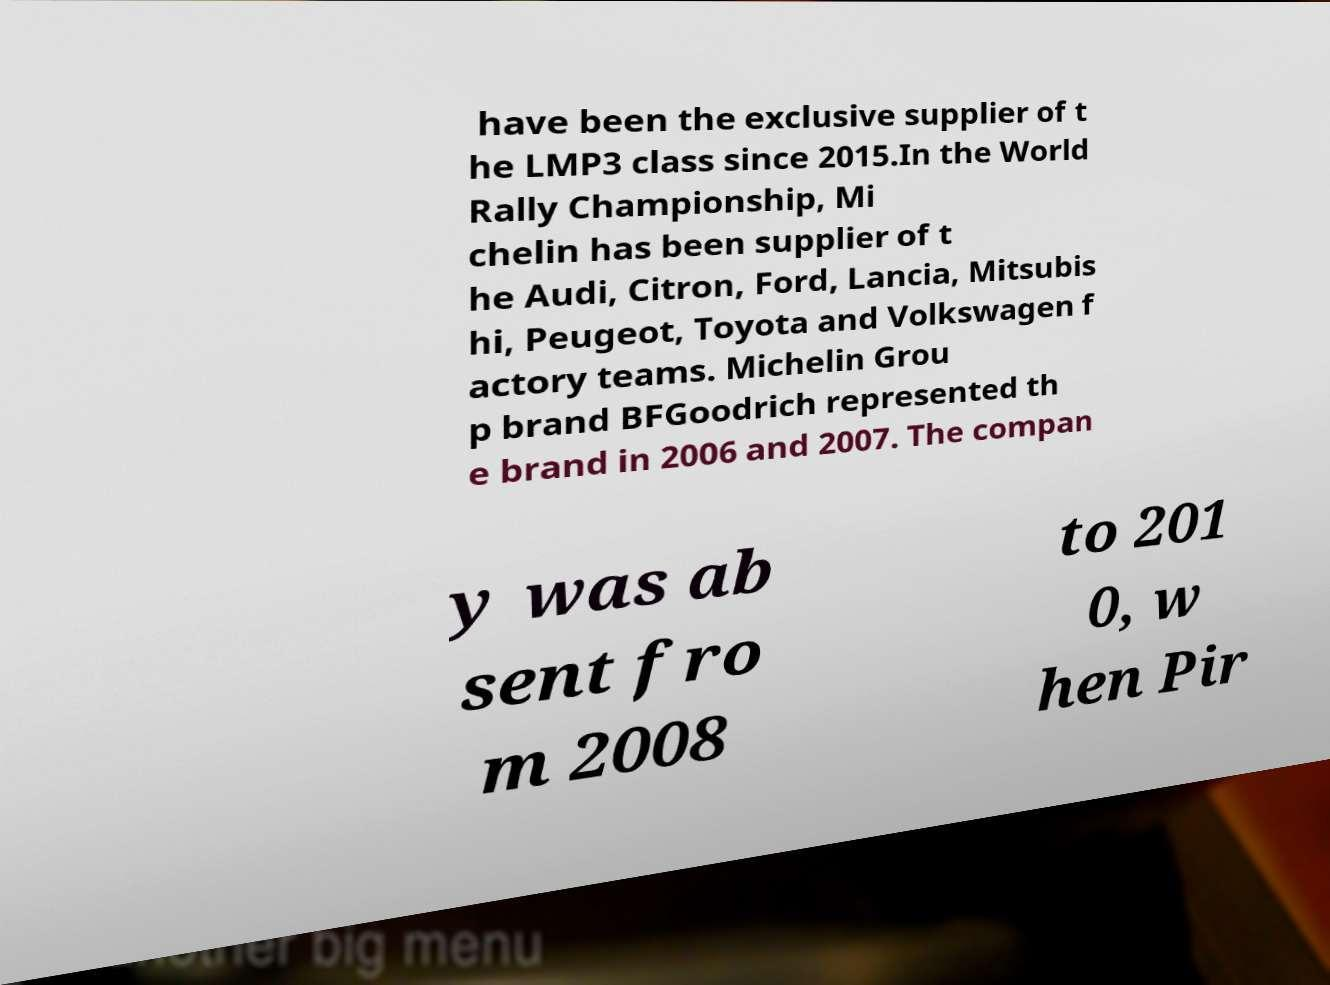Please read and relay the text visible in this image. What does it say? have been the exclusive supplier of t he LMP3 class since 2015.In the World Rally Championship, Mi chelin has been supplier of t he Audi, Citron, Ford, Lancia, Mitsubis hi, Peugeot, Toyota and Volkswagen f actory teams. Michelin Grou p brand BFGoodrich represented th e brand in 2006 and 2007. The compan y was ab sent fro m 2008 to 201 0, w hen Pir 